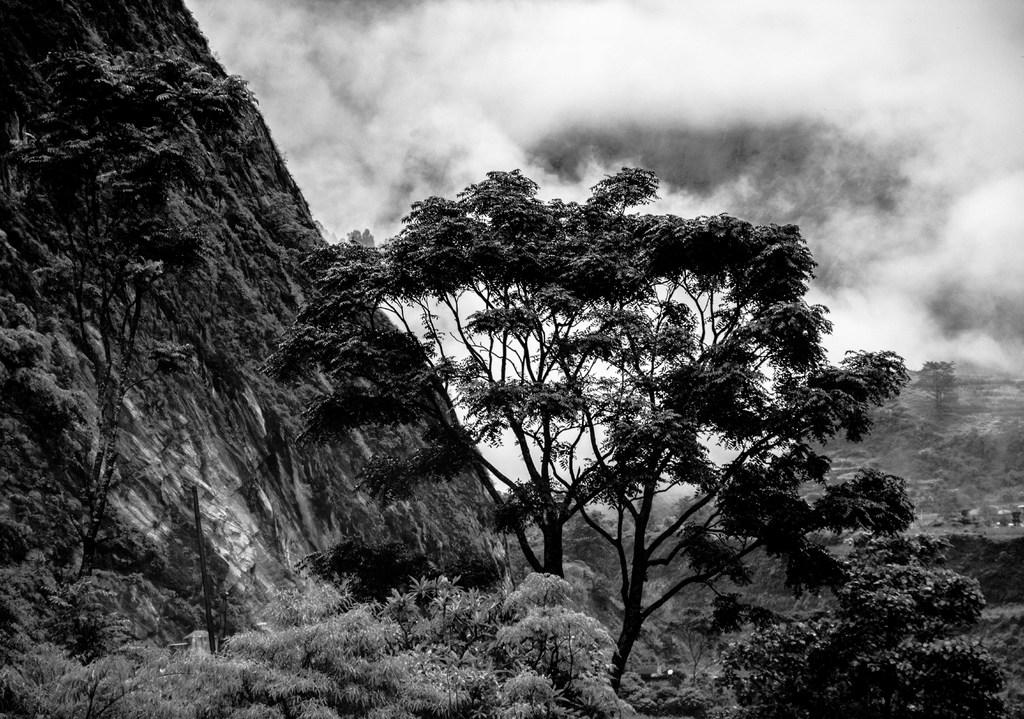What type of vegetation can be seen in the image? There are trees in the image. Where are the trees located in relation to the image? The trees are in the foreground. What else can be seen in the sky in the image? There are clouds visible in the image. What is the color scheme of the image? The image is black and white. What type of stocking is hanging from the tree in the image? There is no stocking hanging from the tree in the image; it is a black and white image with trees and clouds. 